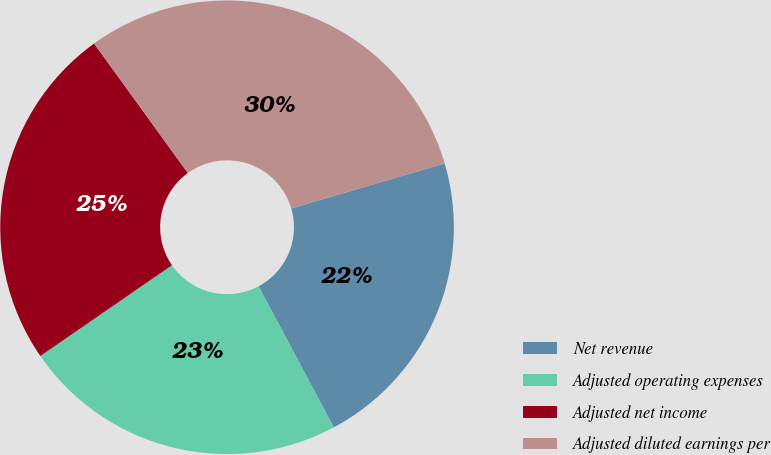Convert chart. <chart><loc_0><loc_0><loc_500><loc_500><pie_chart><fcel>Net revenue<fcel>Adjusted operating expenses<fcel>Adjusted net income<fcel>Adjusted diluted earnings per<nl><fcel>21.74%<fcel>23.19%<fcel>24.64%<fcel>30.43%<nl></chart> 